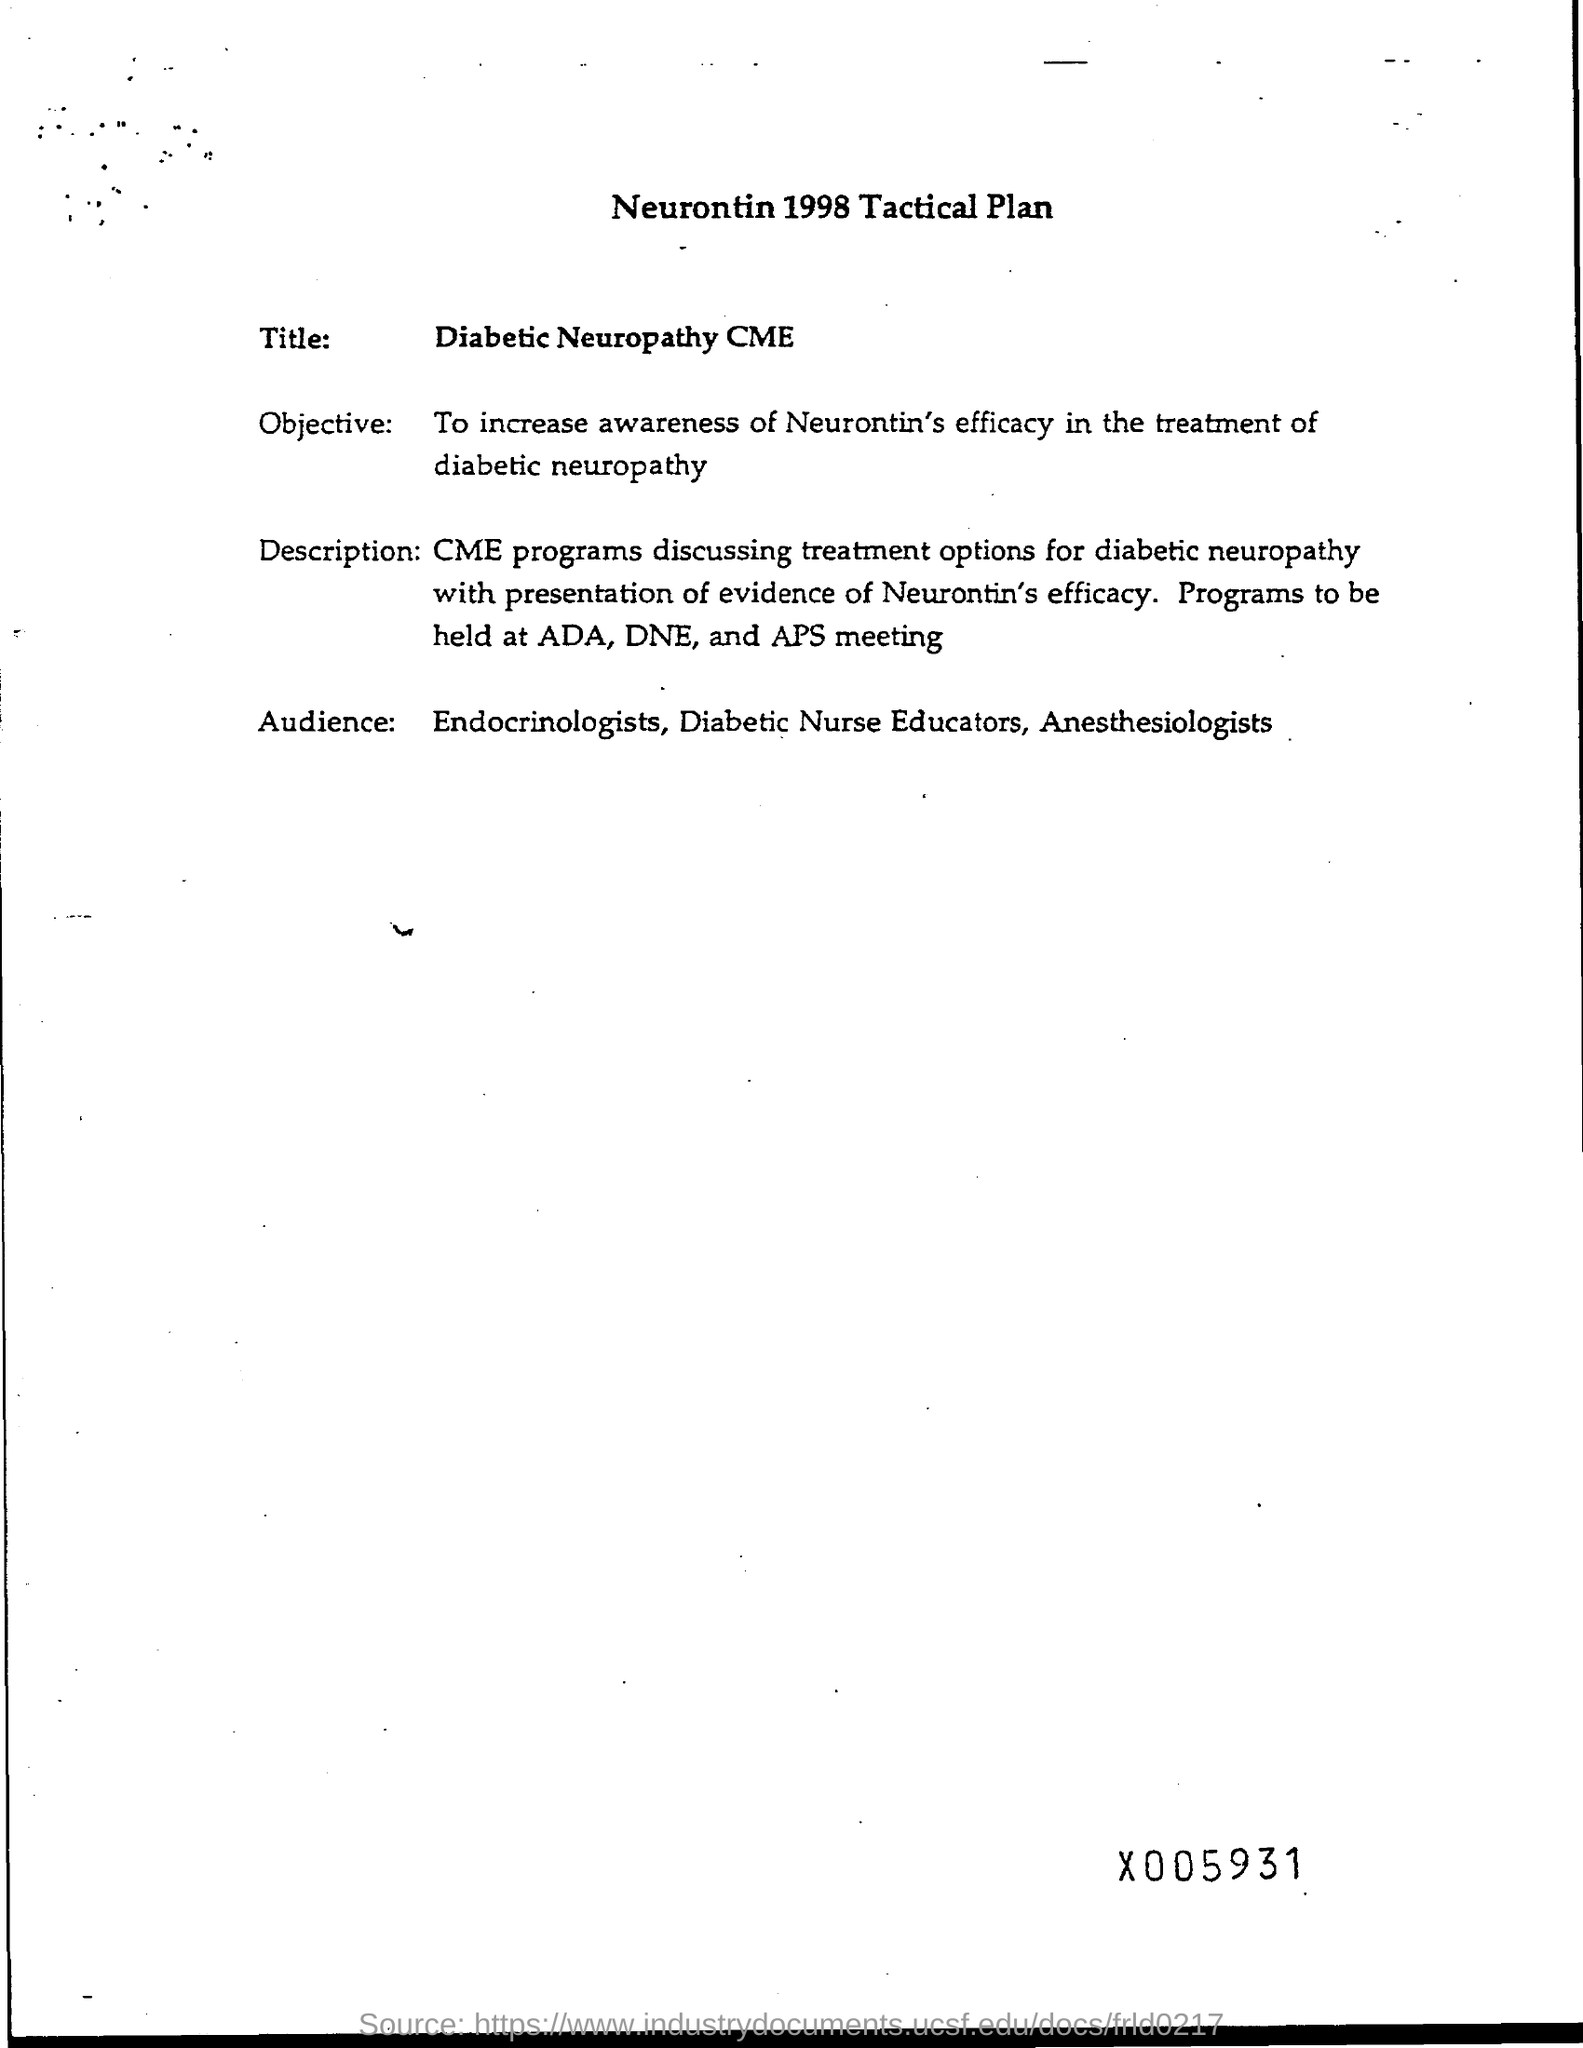What is the Objective?
Your answer should be compact. To increase awareness of Neurontin's efficacy in the treatment of diabetic neuropathy. Where the programs to be held at?
Provide a succinct answer. ADA, DNE, and APS meeting. Who are the Audience?
Your answer should be compact. Endocrinologists, Diabetic Nurse Educators, Anesthesiologists. 